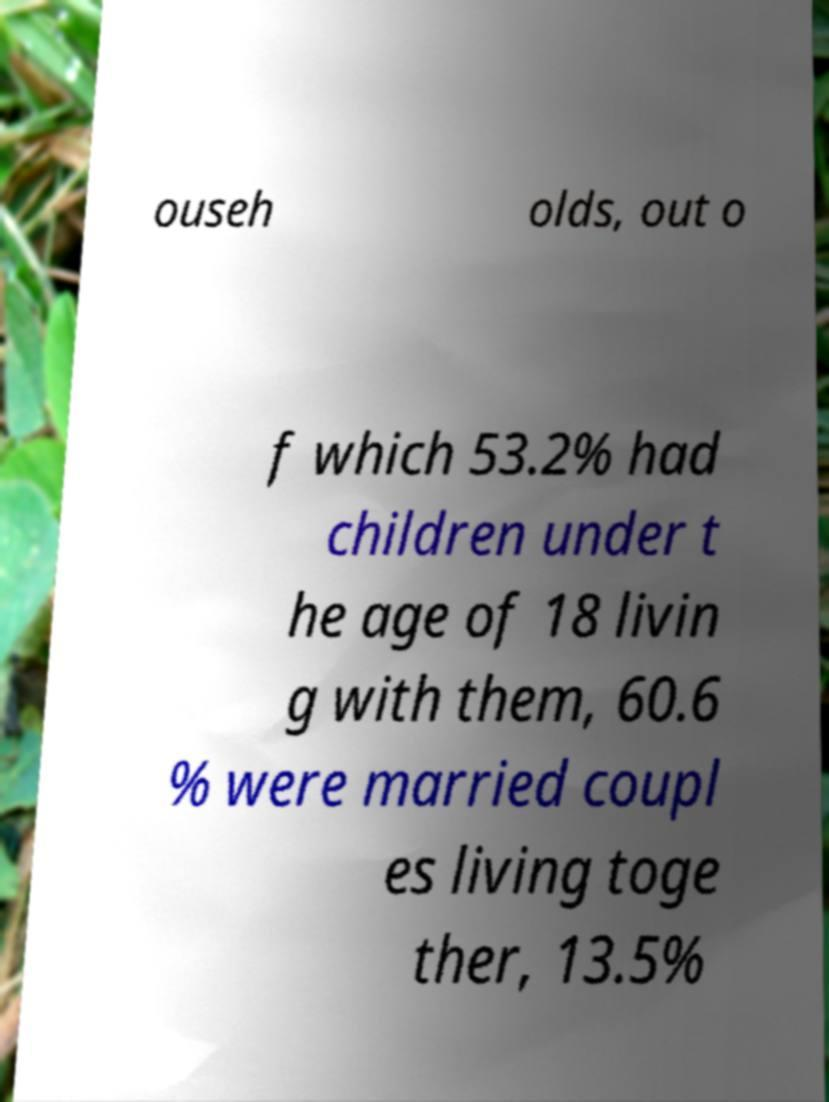Please identify and transcribe the text found in this image. ouseh olds, out o f which 53.2% had children under t he age of 18 livin g with them, 60.6 % were married coupl es living toge ther, 13.5% 